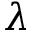<formula> <loc_0><loc_0><loc_500><loc_500>\lambda</formula> 